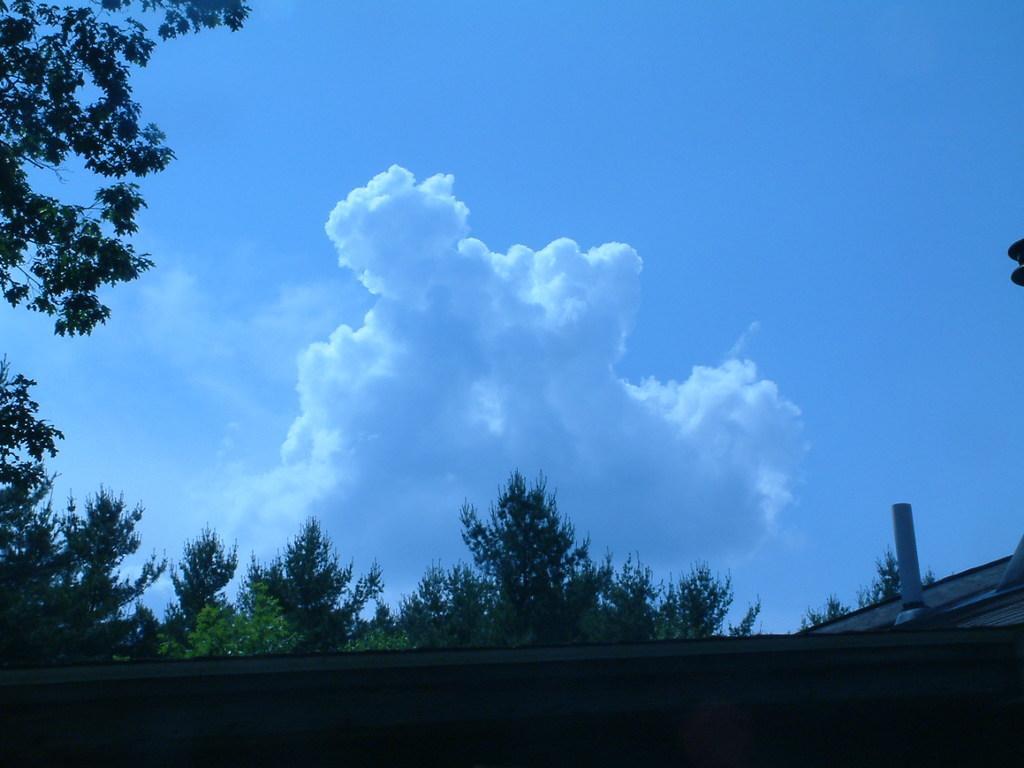In one or two sentences, can you explain what this image depicts? In this image we can see clouds, trees, roof and sky. 